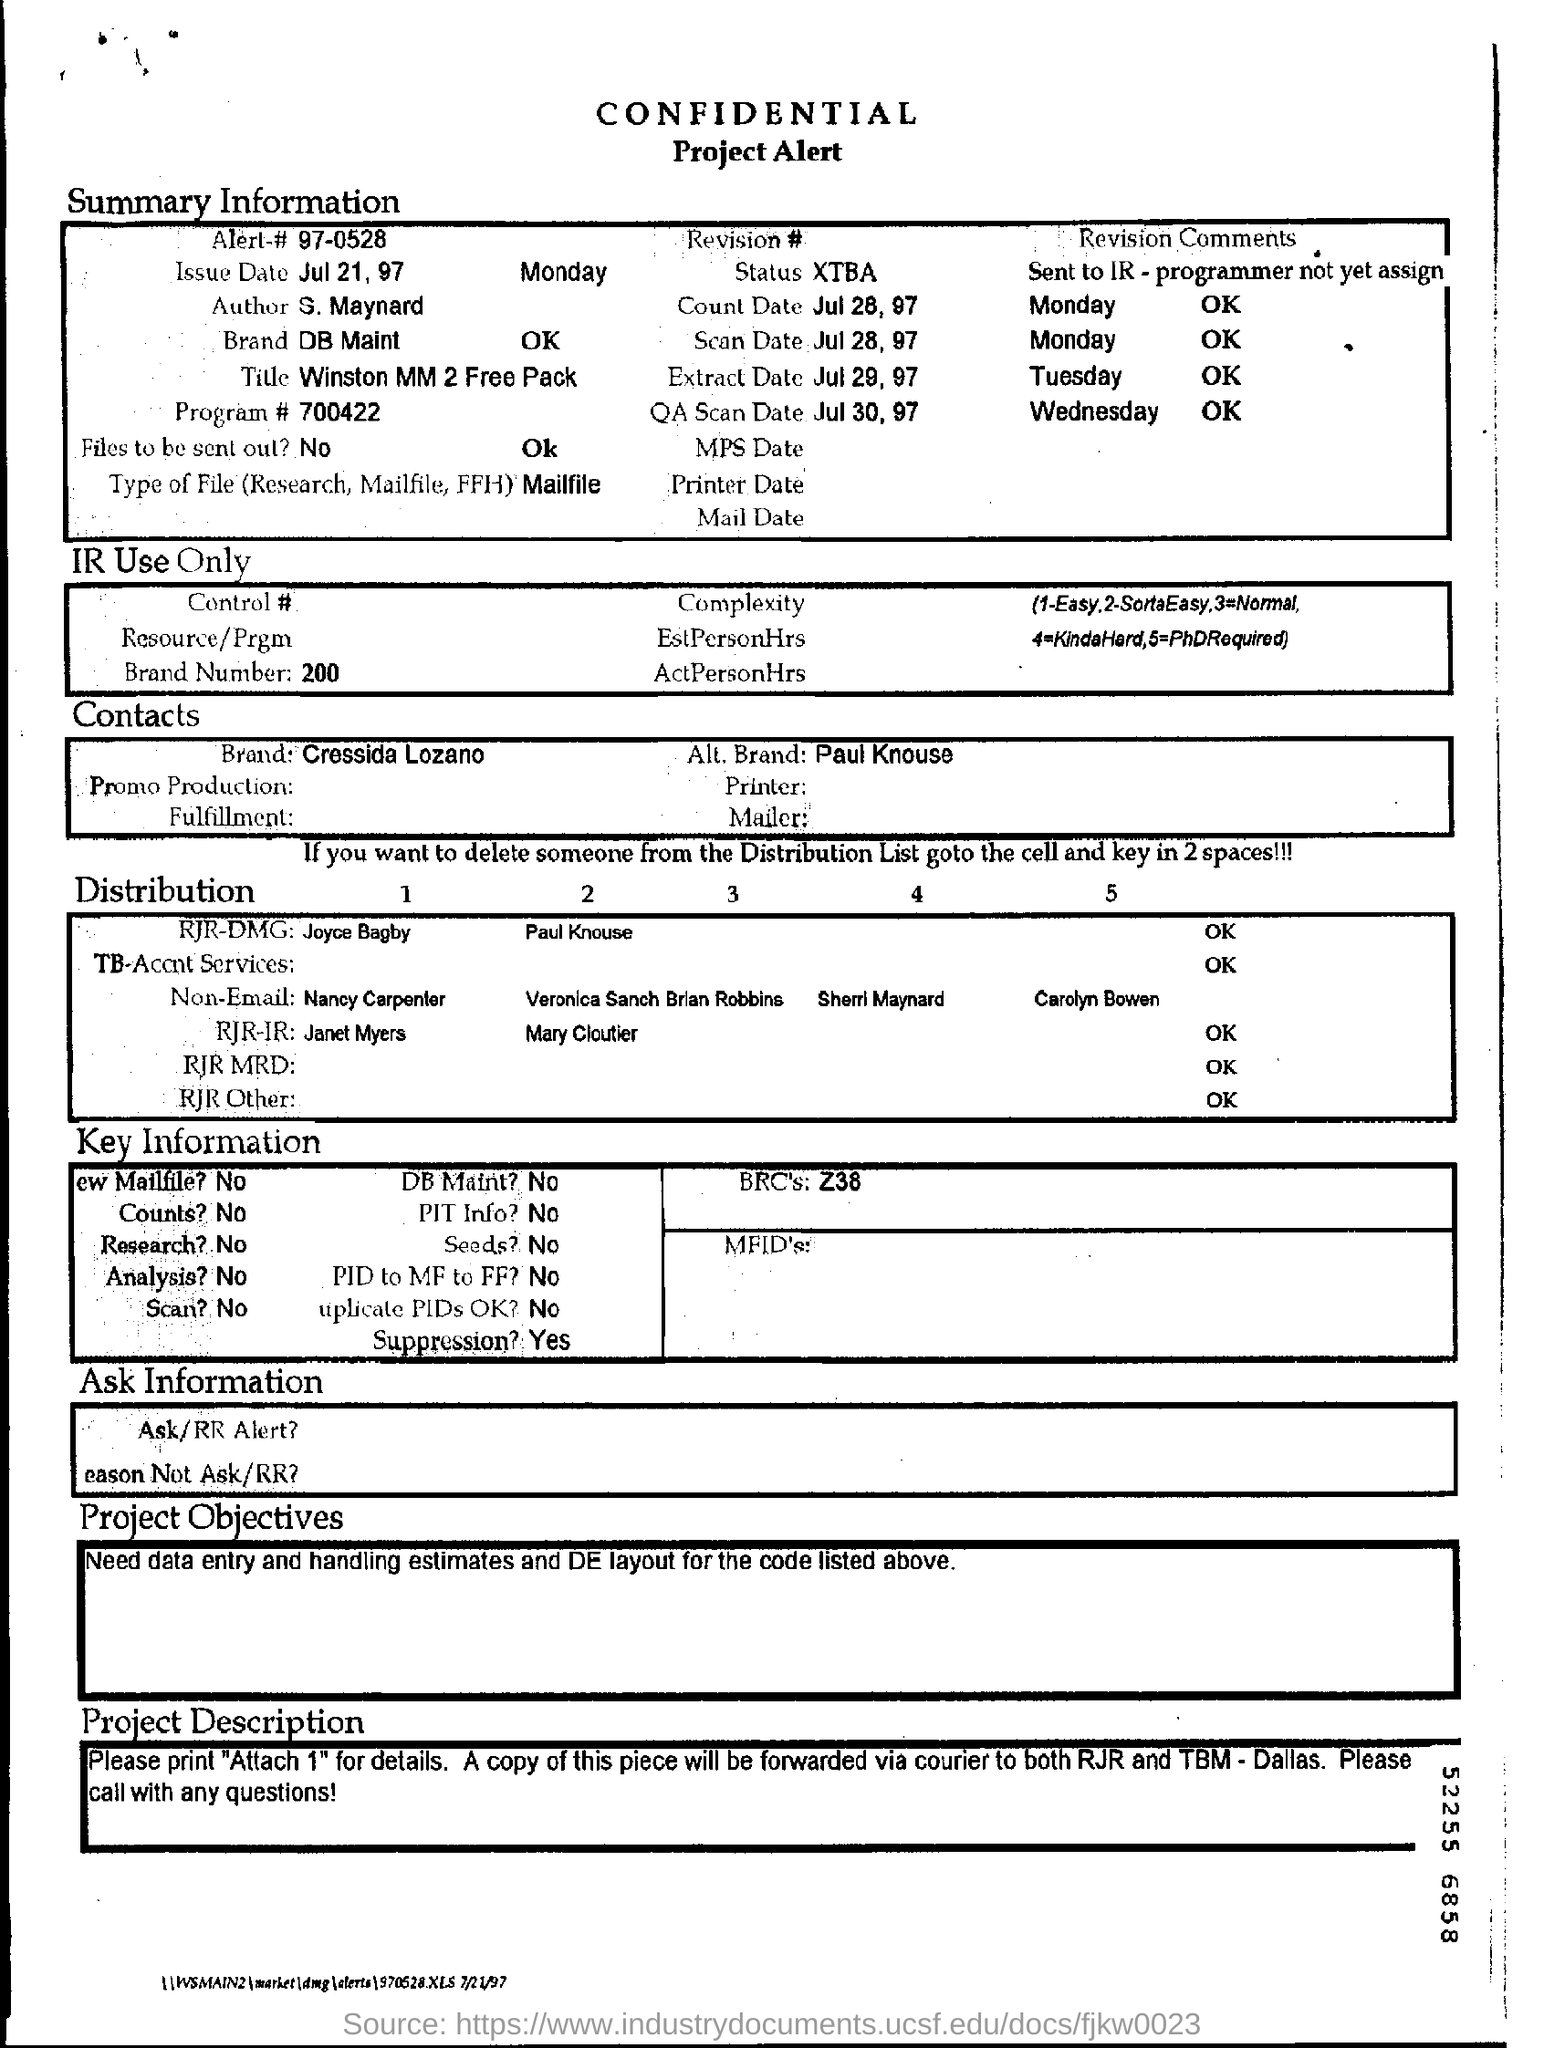Mention a couple of crucial points in this snapshot. The issue date mentioned in the summary information is July 21, 1997. It is not the intention to distribute the files. The name of the brand mentioned in the contact is Cressida Lozano. 